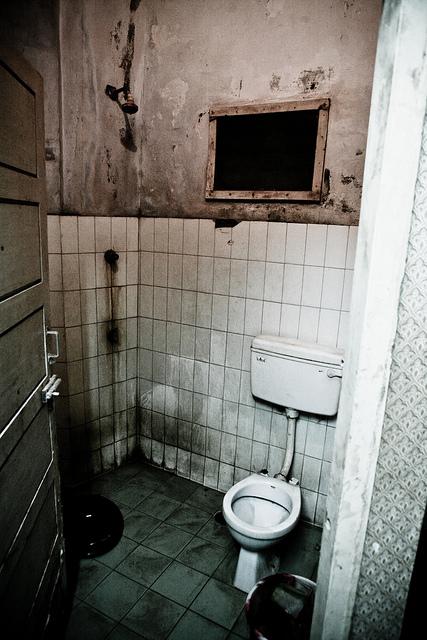Is there toilet paper in this bathroom?
Concise answer only. No. Is the restroom gross?
Keep it brief. Yes. What happened to the room?
Quick response, please. Dirty. What is the large rectangle on the wall for?
Write a very short answer. Mirror. What is the largest diagonal visible on the wall next to the door?
Write a very short answer. Window. 